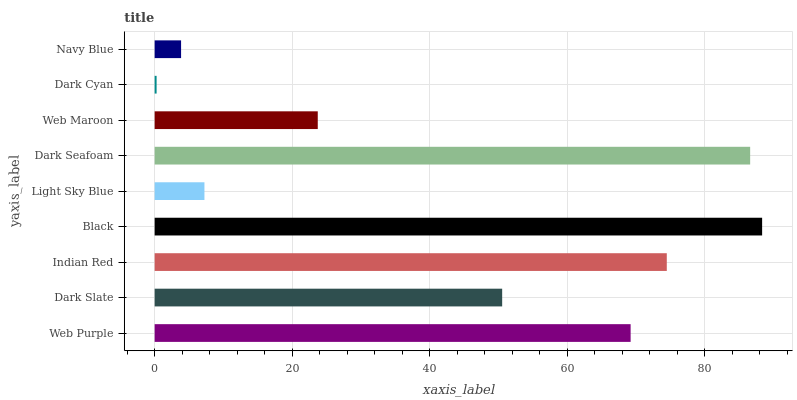Is Dark Cyan the minimum?
Answer yes or no. Yes. Is Black the maximum?
Answer yes or no. Yes. Is Dark Slate the minimum?
Answer yes or no. No. Is Dark Slate the maximum?
Answer yes or no. No. Is Web Purple greater than Dark Slate?
Answer yes or no. Yes. Is Dark Slate less than Web Purple?
Answer yes or no. Yes. Is Dark Slate greater than Web Purple?
Answer yes or no. No. Is Web Purple less than Dark Slate?
Answer yes or no. No. Is Dark Slate the high median?
Answer yes or no. Yes. Is Dark Slate the low median?
Answer yes or no. Yes. Is Web Maroon the high median?
Answer yes or no. No. Is Indian Red the low median?
Answer yes or no. No. 